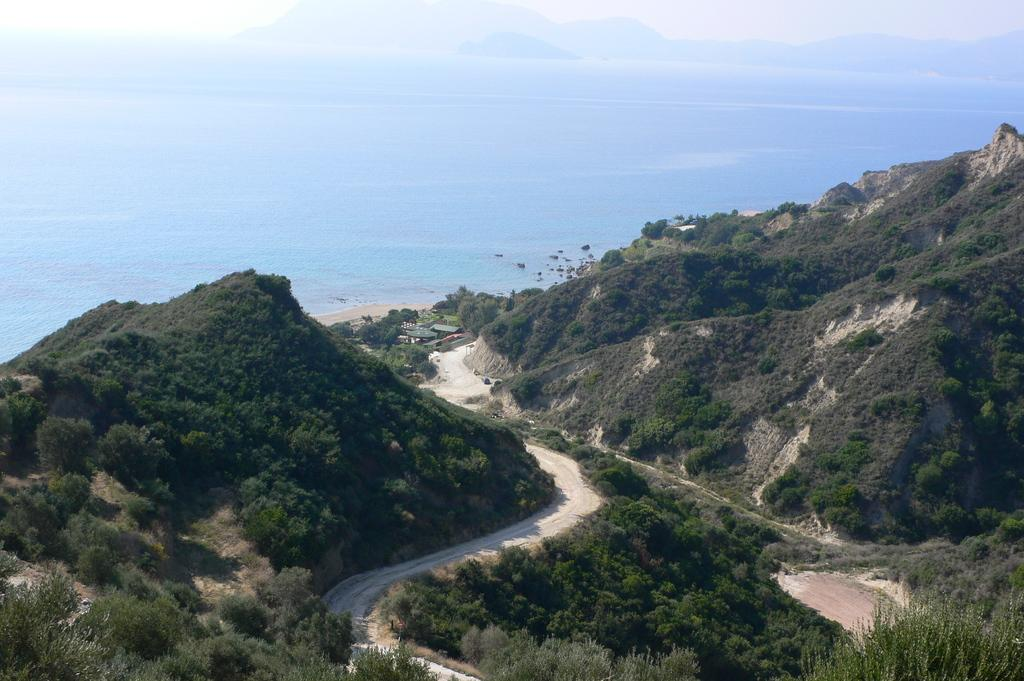What is the main feature of the image? There is a road in the image. Where is the road located? The road is situated between hills. What else can be seen in the image besides the road? There is water visible in the image. What type of payment is accepted at the nation depicted in the image? There is no nation depicted in the image, so it is not possible to determine what type of payment might be accepted. 